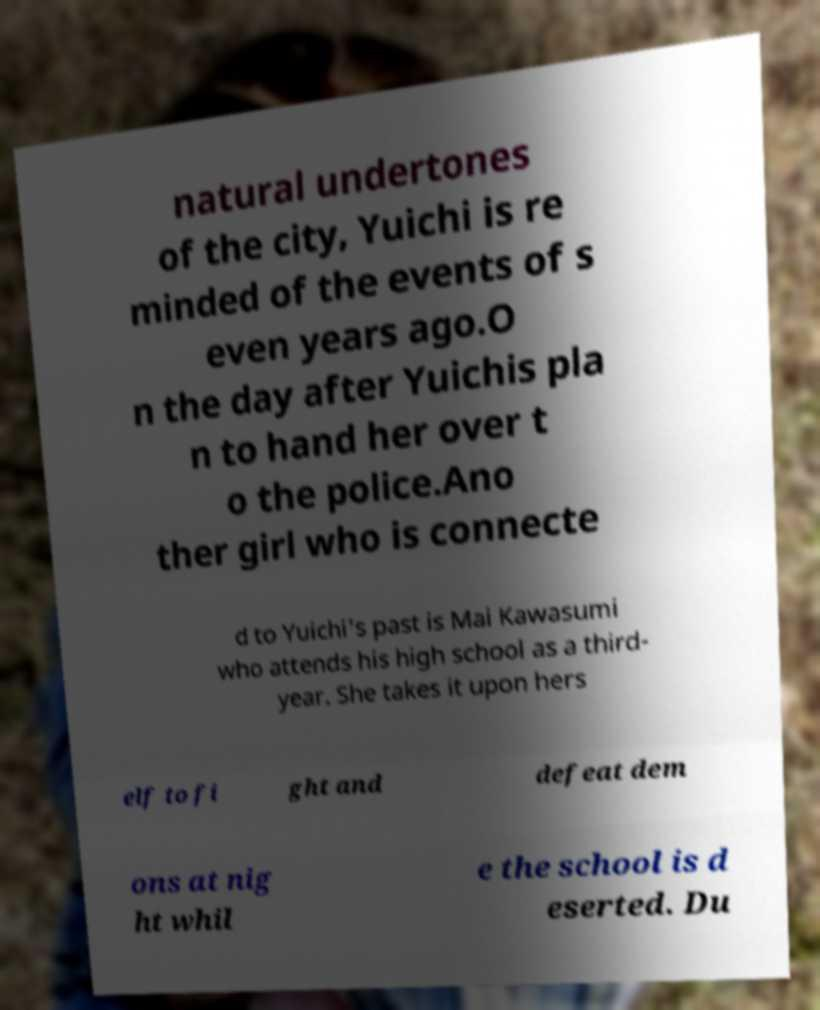Please identify and transcribe the text found in this image. natural undertones of the city, Yuichi is re minded of the events of s even years ago.O n the day after Yuichis pla n to hand her over t o the police.Ano ther girl who is connecte d to Yuichi's past is Mai Kawasumi who attends his high school as a third- year. She takes it upon hers elf to fi ght and defeat dem ons at nig ht whil e the school is d eserted. Du 